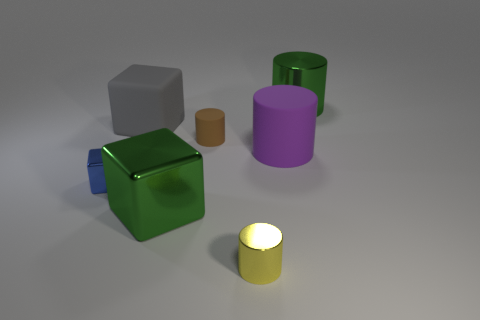There is a big cube behind the big green shiny thing in front of the green shiny thing behind the blue object; what is its color?
Provide a short and direct response. Gray. Are there any other things that have the same material as the yellow thing?
Your response must be concise. Yes. There is a green metal thing that is the same shape as the yellow metallic thing; what is its size?
Give a very brief answer. Large. Are there fewer blue metal objects that are to the right of the purple matte cylinder than green metallic things to the right of the small rubber cylinder?
Provide a short and direct response. Yes. What shape is the tiny thing that is both behind the big metal block and on the right side of the gray rubber block?
Make the answer very short. Cylinder. There is a gray object that is made of the same material as the small brown cylinder; what is its size?
Give a very brief answer. Large. There is a tiny metal cylinder; is its color the same as the large cube that is in front of the brown matte cylinder?
Offer a very short reply. No. There is a big thing that is to the left of the big purple rubber cylinder and in front of the large gray block; what is it made of?
Your answer should be very brief. Metal. There is a metallic cylinder that is the same color as the big metallic cube; what size is it?
Ensure brevity in your answer.  Large. There is a metal object behind the tiny blue thing; does it have the same shape as the metal object on the left side of the green metallic block?
Offer a terse response. No. 